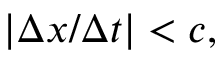Convert formula to latex. <formula><loc_0><loc_0><loc_500><loc_500>| \Delta x / \Delta t | < c ,</formula> 